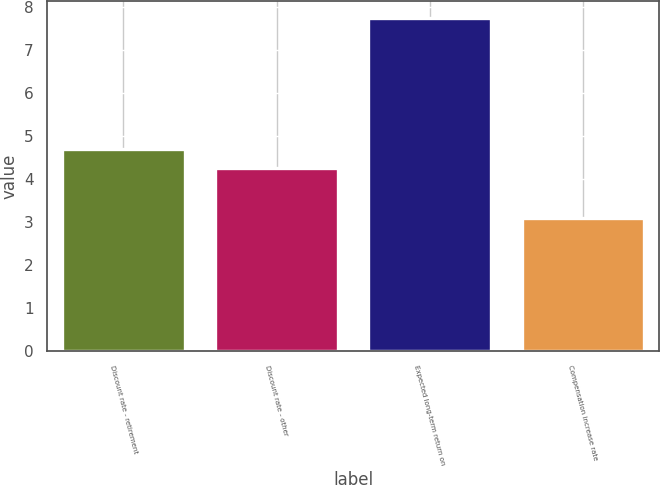Convert chart. <chart><loc_0><loc_0><loc_500><loc_500><bar_chart><fcel>Discount rate - retirement<fcel>Discount rate - other<fcel>Expected long-term return on<fcel>Compensation increase rate<nl><fcel>4.71<fcel>4.25<fcel>7.75<fcel>3.1<nl></chart> 